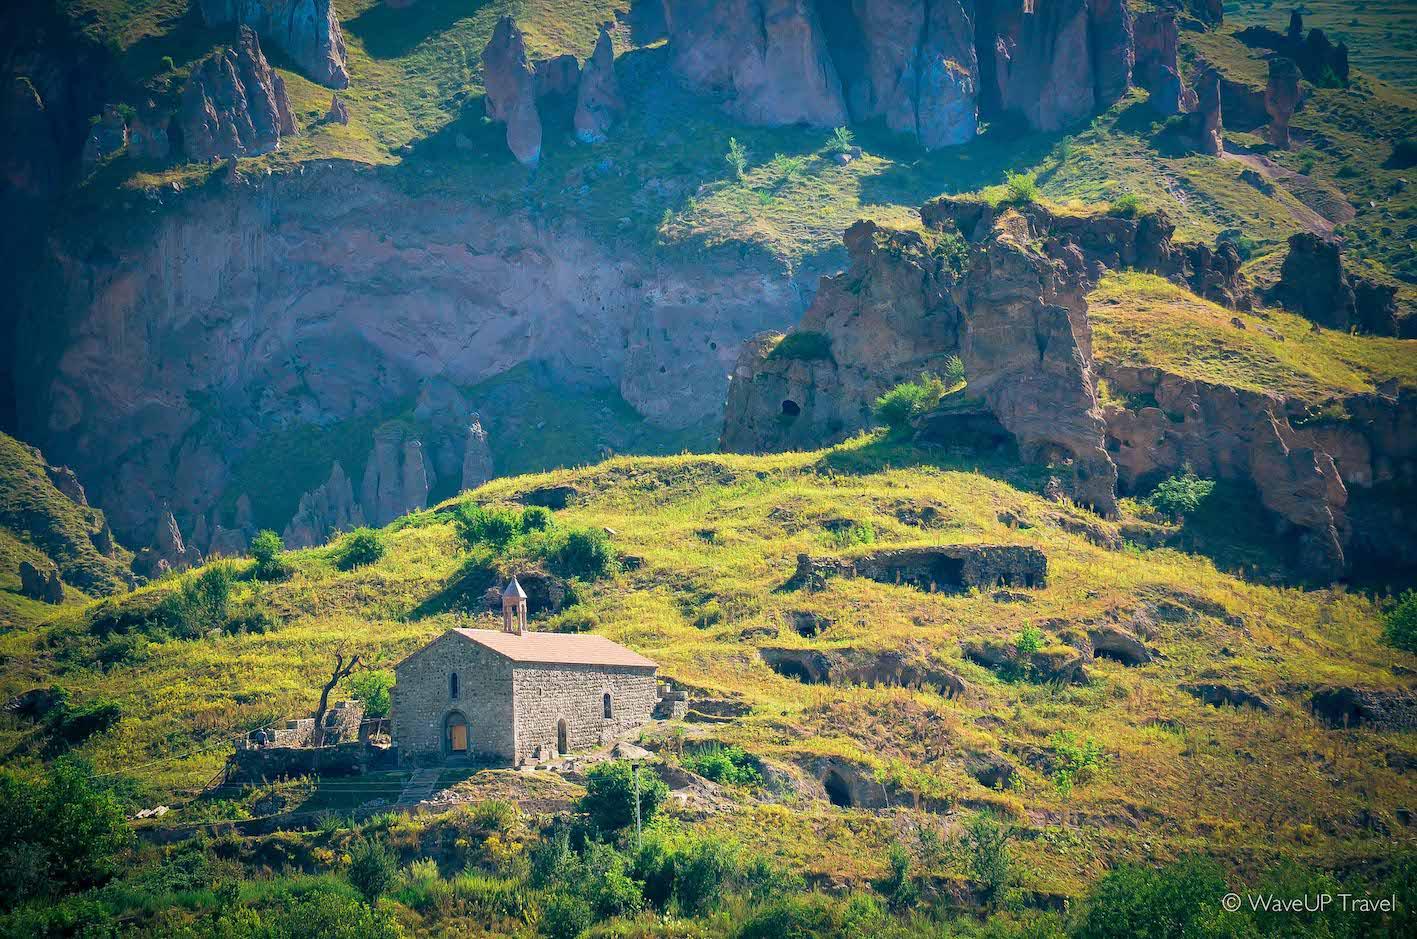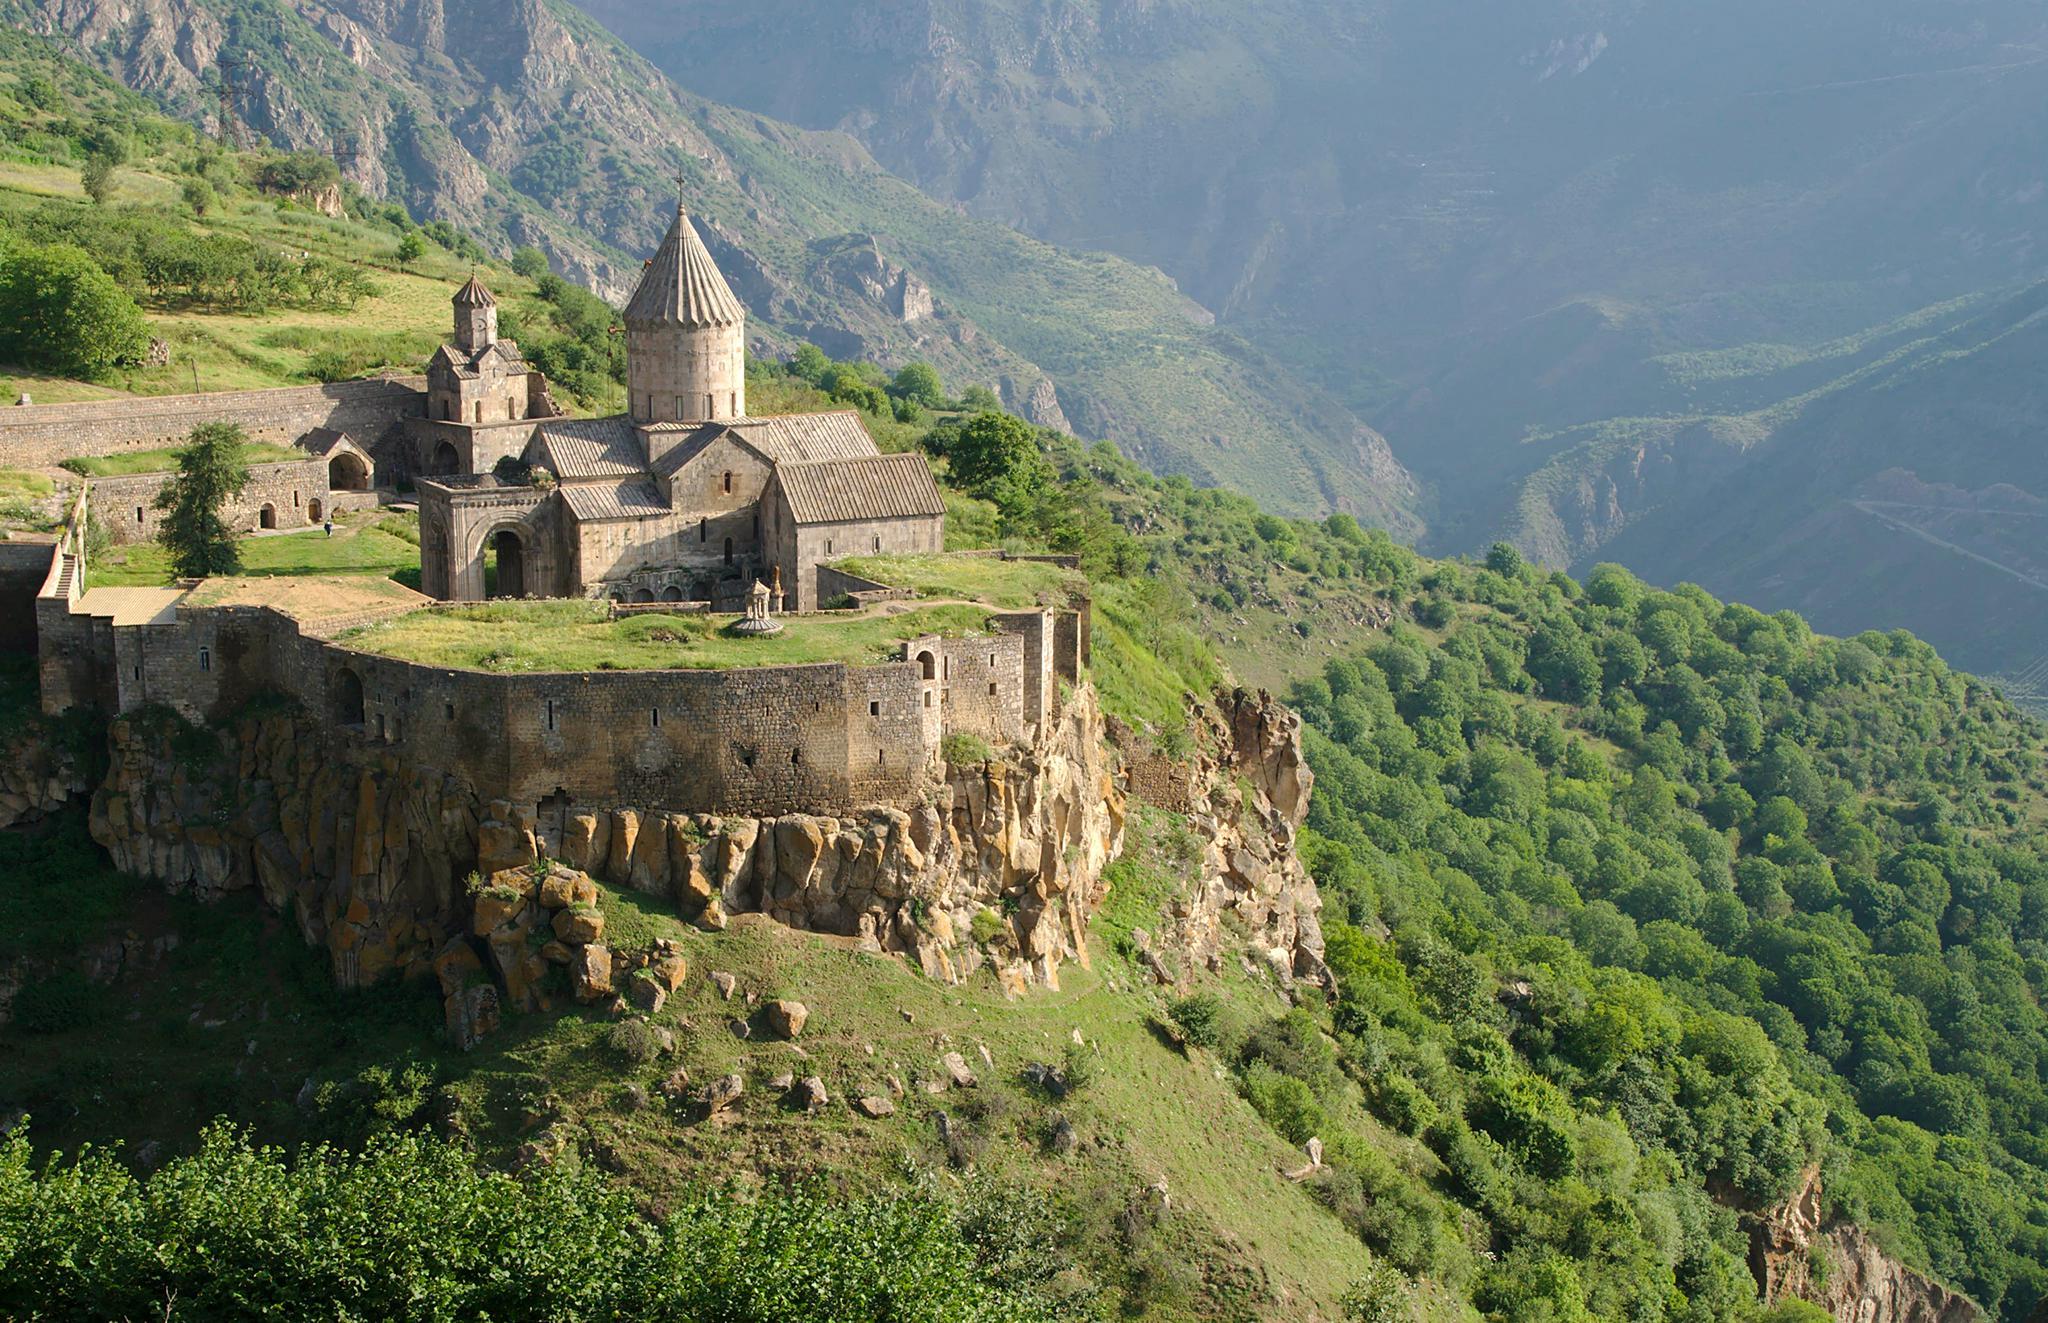The first image is the image on the left, the second image is the image on the right. Analyze the images presented: Is the assertion "Each set of images is actually just two different views of the same building." valid? Answer yes or no. No. 